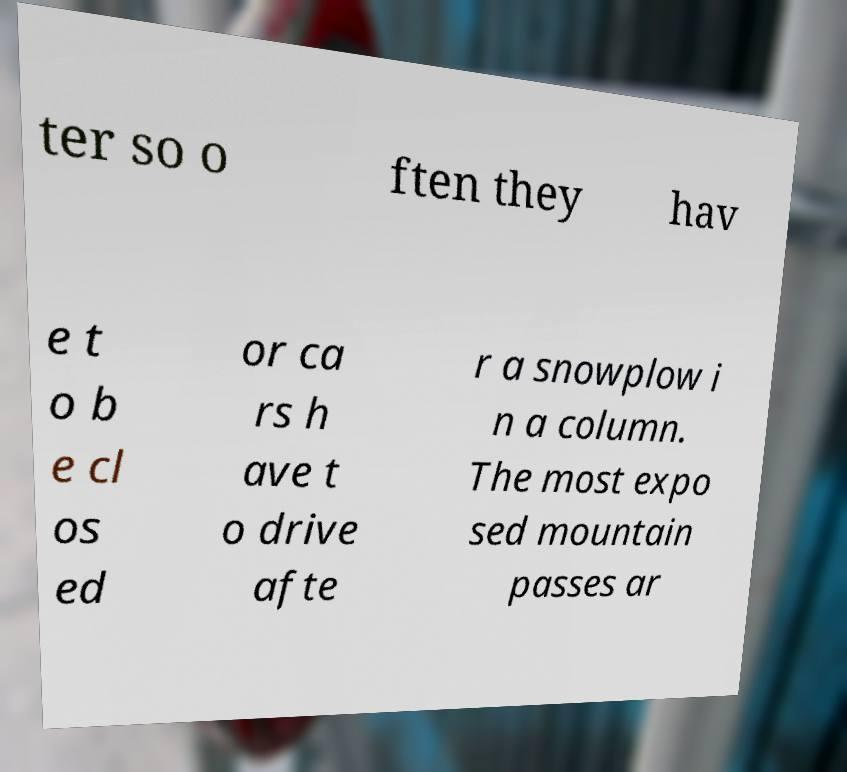Can you accurately transcribe the text from the provided image for me? ter so o ften they hav e t o b e cl os ed or ca rs h ave t o drive afte r a snowplow i n a column. The most expo sed mountain passes ar 